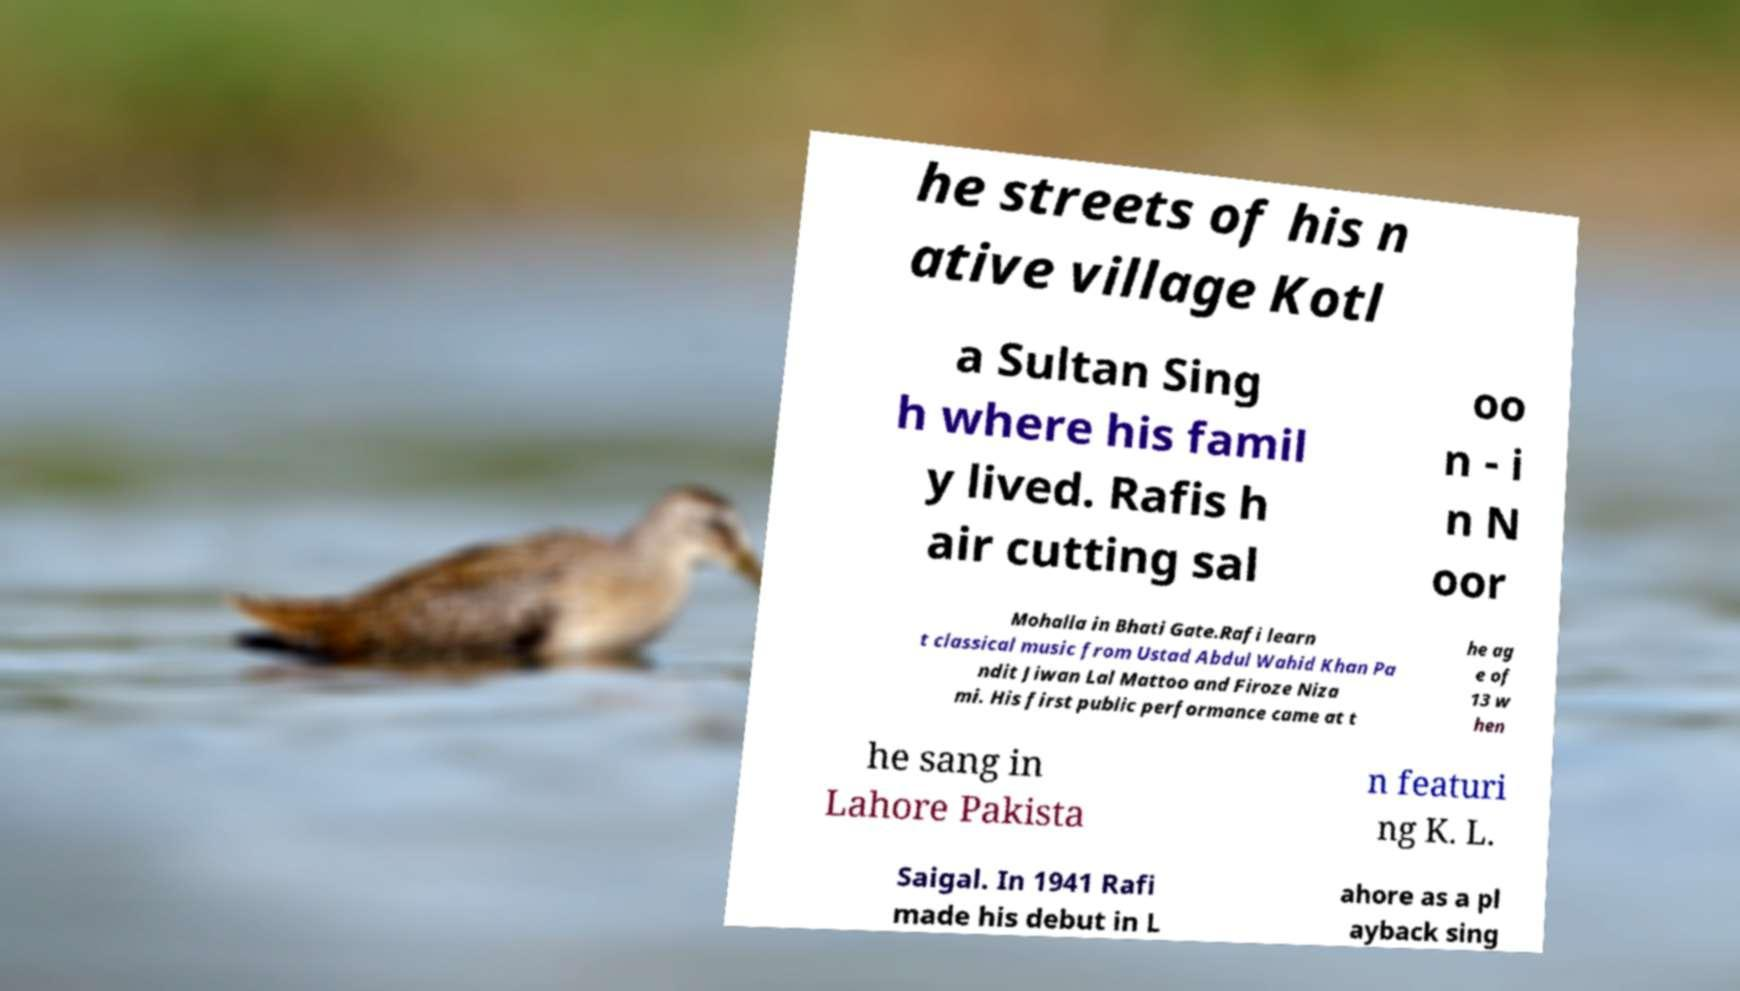I need the written content from this picture converted into text. Can you do that? he streets of his n ative village Kotl a Sultan Sing h where his famil y lived. Rafis h air cutting sal oo n - i n N oor Mohalla in Bhati Gate.Rafi learn t classical music from Ustad Abdul Wahid Khan Pa ndit Jiwan Lal Mattoo and Firoze Niza mi. His first public performance came at t he ag e of 13 w hen he sang in Lahore Pakista n featuri ng K. L. Saigal. In 1941 Rafi made his debut in L ahore as a pl ayback sing 